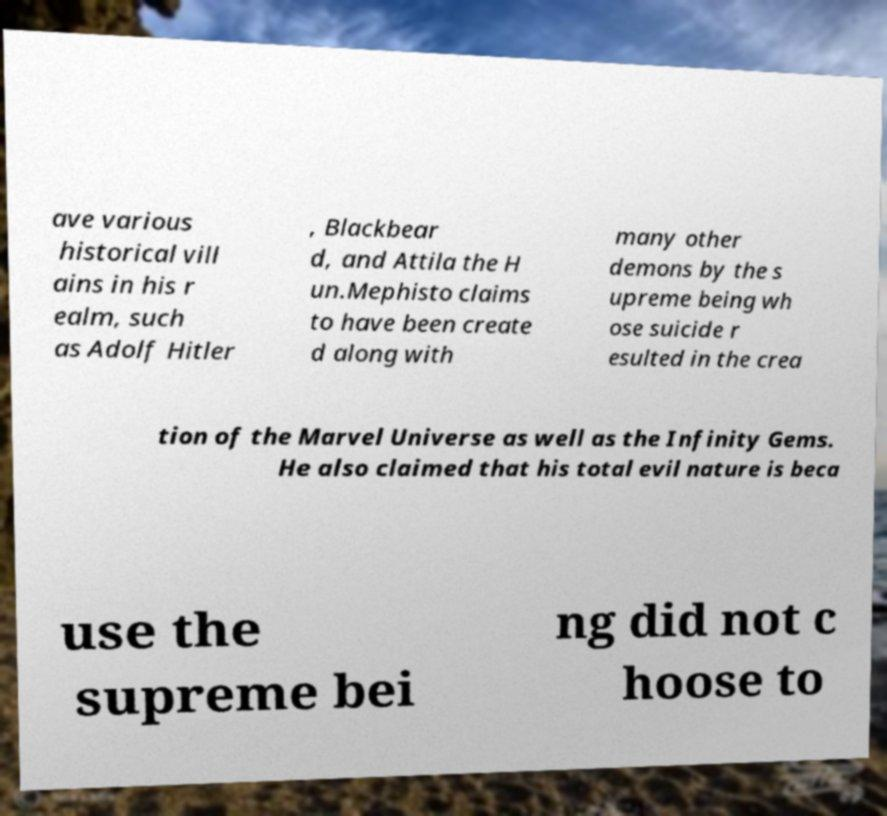Can you accurately transcribe the text from the provided image for me? ave various historical vill ains in his r ealm, such as Adolf Hitler , Blackbear d, and Attila the H un.Mephisto claims to have been create d along with many other demons by the s upreme being wh ose suicide r esulted in the crea tion of the Marvel Universe as well as the Infinity Gems. He also claimed that his total evil nature is beca use the supreme bei ng did not c hoose to 